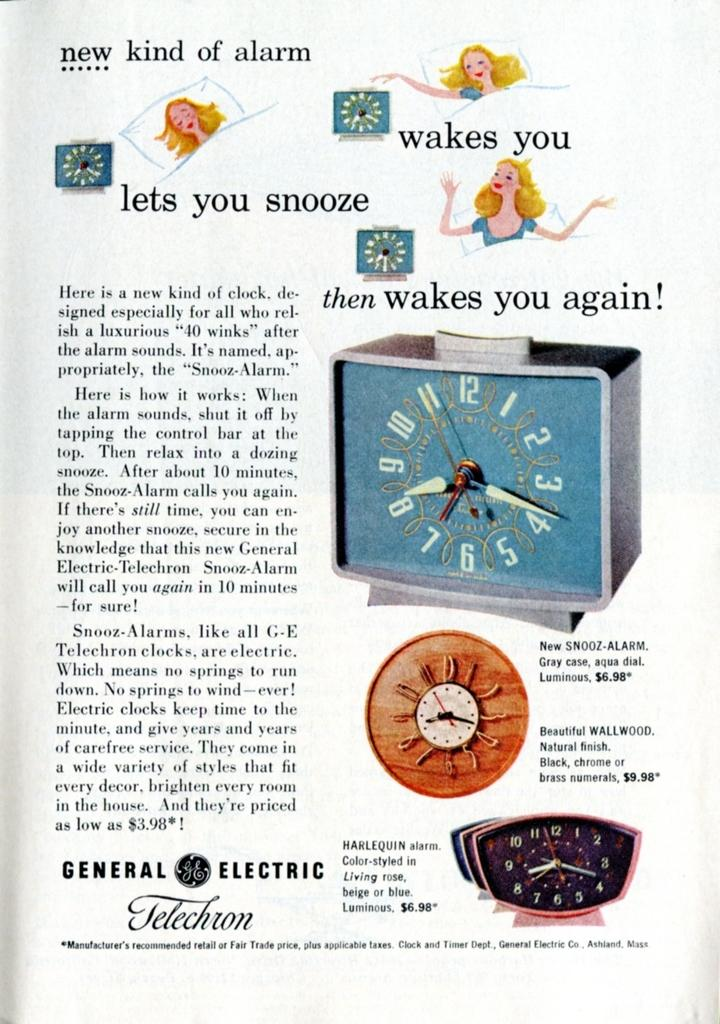<image>
Create a compact narrative representing the image presented. Advertisement for General Electric that says "New kind of alarm" on top. 